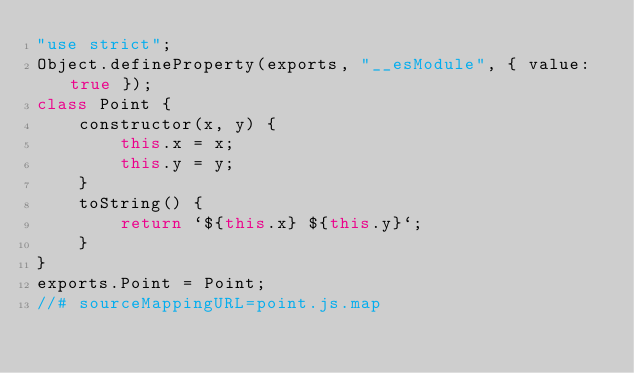<code> <loc_0><loc_0><loc_500><loc_500><_JavaScript_>"use strict";
Object.defineProperty(exports, "__esModule", { value: true });
class Point {
    constructor(x, y) {
        this.x = x;
        this.y = y;
    }
    toString() {
        return `${this.x} ${this.y}`;
    }
}
exports.Point = Point;
//# sourceMappingURL=point.js.map</code> 